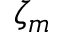<formula> <loc_0><loc_0><loc_500><loc_500>\zeta _ { m }</formula> 